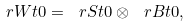<formula> <loc_0><loc_0><loc_500><loc_500>\ r W t { 0 } = \ r S t { 0 } \otimes \ r B t { 0 } ,</formula> 